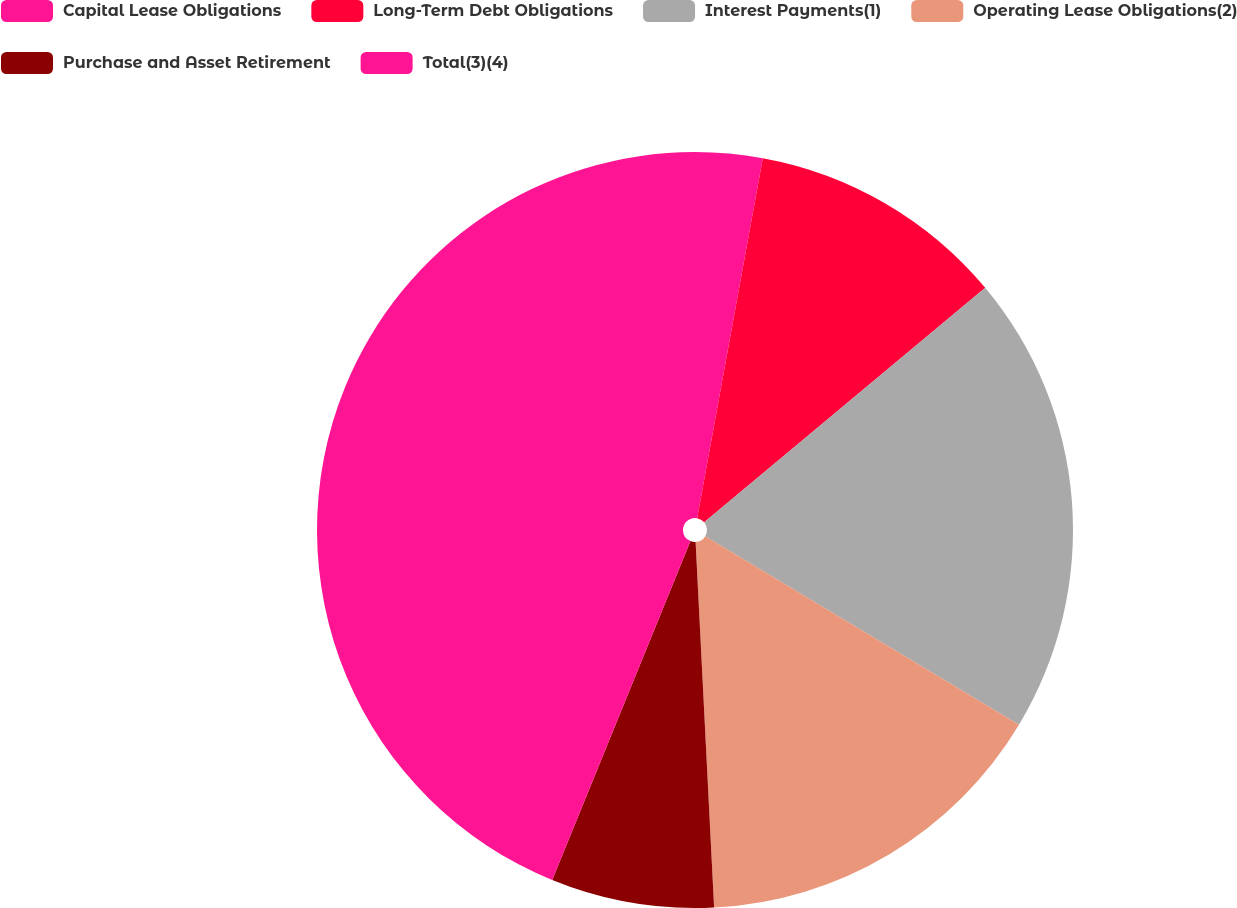Convert chart to OTSL. <chart><loc_0><loc_0><loc_500><loc_500><pie_chart><fcel>Capital Lease Obligations<fcel>Long-Term Debt Obligations<fcel>Interest Payments(1)<fcel>Operating Lease Obligations(2)<fcel>Purchase and Asset Retirement<fcel>Total(3)(4)<nl><fcel>2.87%<fcel>11.06%<fcel>19.68%<fcel>15.58%<fcel>6.97%<fcel>43.83%<nl></chart> 